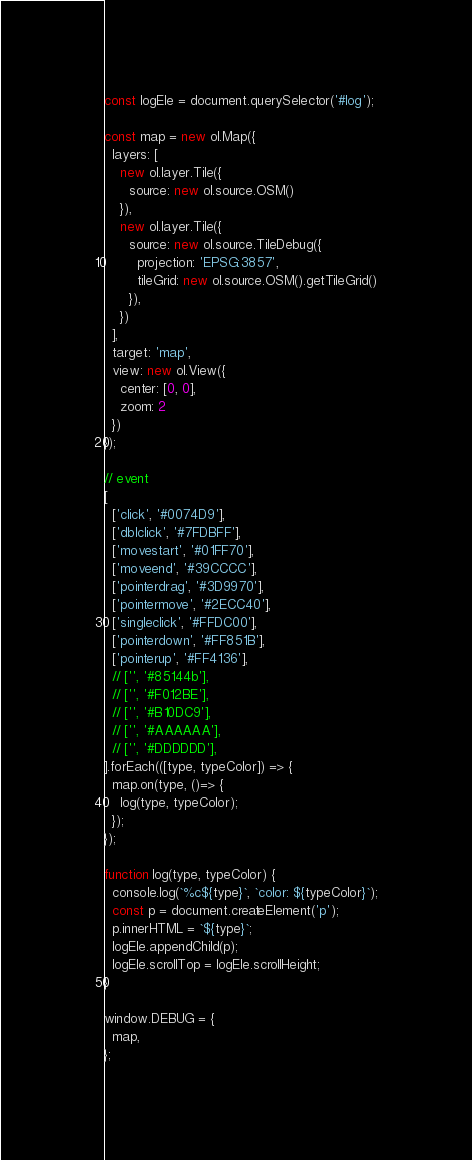Convert code to text. <code><loc_0><loc_0><loc_500><loc_500><_JavaScript_>const logEle = document.querySelector('#log');

const map = new ol.Map({
  layers: [
    new ol.layer.Tile({
      source: new ol.source.OSM()
    }),
    new ol.layer.Tile({
      source: new ol.source.TileDebug({
        projection: 'EPSG:3857',
        tileGrid: new ol.source.OSM().getTileGrid()
      }),
    })
  ],
  target: 'map',
  view: new ol.View({
    center: [0, 0],
    zoom: 2
  })
});

// event
[
  ['click', '#0074D9'],
  ['dblclick', '#7FDBFF'],
  ['movestart', '#01FF70'],
  ['moveend', '#39CCCC'],
  ['pointerdrag', '#3D9970'],
  ['pointermove', '#2ECC40'],
  ['singleclick', '#FFDC00'],
  ['pointerdown', '#FF851B'],
  ['pointerup', '#FF4136'],
  // ['', '#85144b'],
  // ['', '#F012BE'],
  // ['', '#B10DC9'],
  // ['', '#AAAAAA'],
  // ['', '#DDDDDD'],
].forEach(([type, typeColor]) => {
  map.on(type, ()=> {
    log(type, typeColor);
  });
});

function log(type, typeColor) {
  console.log(`%c${type}`, `color: ${typeColor}`);
  const p = document.createElement('p');
  p.innerHTML = `${type}`;
  logEle.appendChild(p);
  logEle.scrollTop = logEle.scrollHeight;
}

window.DEBUG = {
  map,
};
</code> 